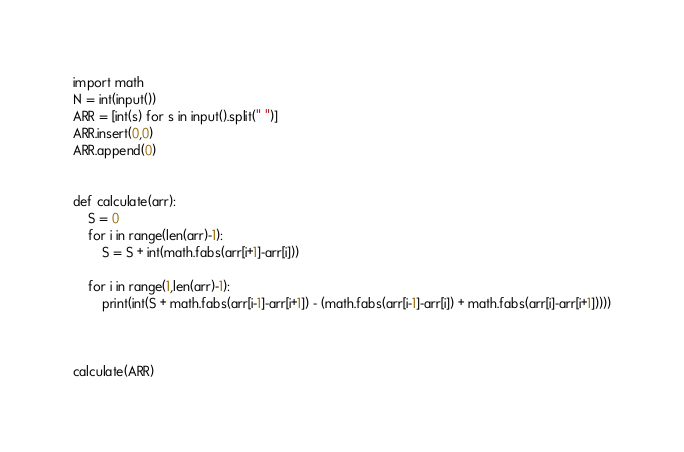Convert code to text. <code><loc_0><loc_0><loc_500><loc_500><_Python_>import math
N = int(input())
ARR = [int(s) for s in input().split(" ")]
ARR.insert(0,0)
ARR.append(0)


def calculate(arr):
    S = 0
    for i in range(len(arr)-1):
        S = S + int(math.fabs(arr[i+1]-arr[i]))

    for i in range(1,len(arr)-1):
        print(int(S + math.fabs(arr[i-1]-arr[i+1]) - (math.fabs(arr[i-1]-arr[i]) + math.fabs(arr[i]-arr[i+1]))))



calculate(ARR)
</code> 